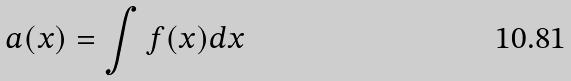Convert formula to latex. <formula><loc_0><loc_0><loc_500><loc_500>a ( x ) = \int f ( x ) d x</formula> 